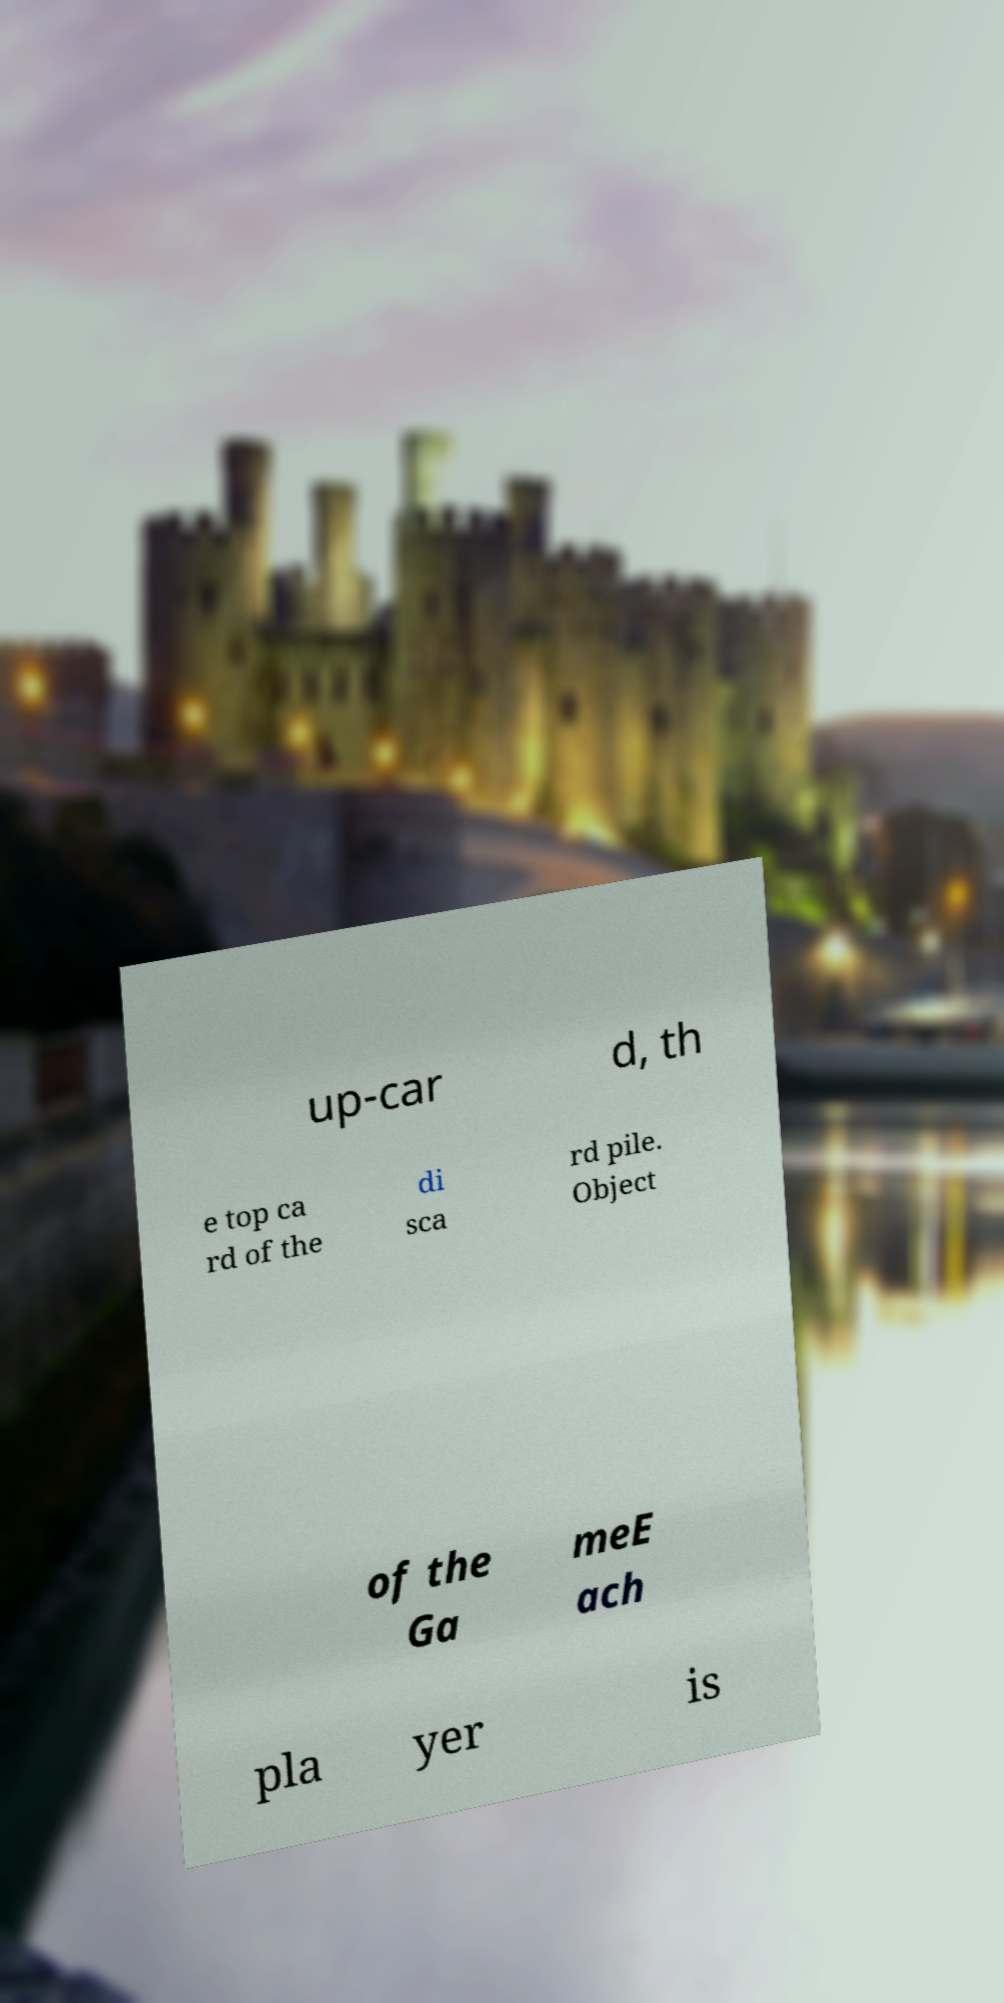Could you extract and type out the text from this image? up-car d, th e top ca rd of the di sca rd pile. Object of the Ga meE ach pla yer is 